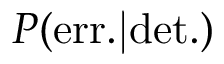<formula> <loc_0><loc_0><loc_500><loc_500>P ( e r r . | d e t . )</formula> 